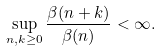Convert formula to latex. <formula><loc_0><loc_0><loc_500><loc_500>\sup _ { n , k \geq 0 } \frac { \beta ( n + k ) } { \beta ( n ) } < \infty .</formula> 